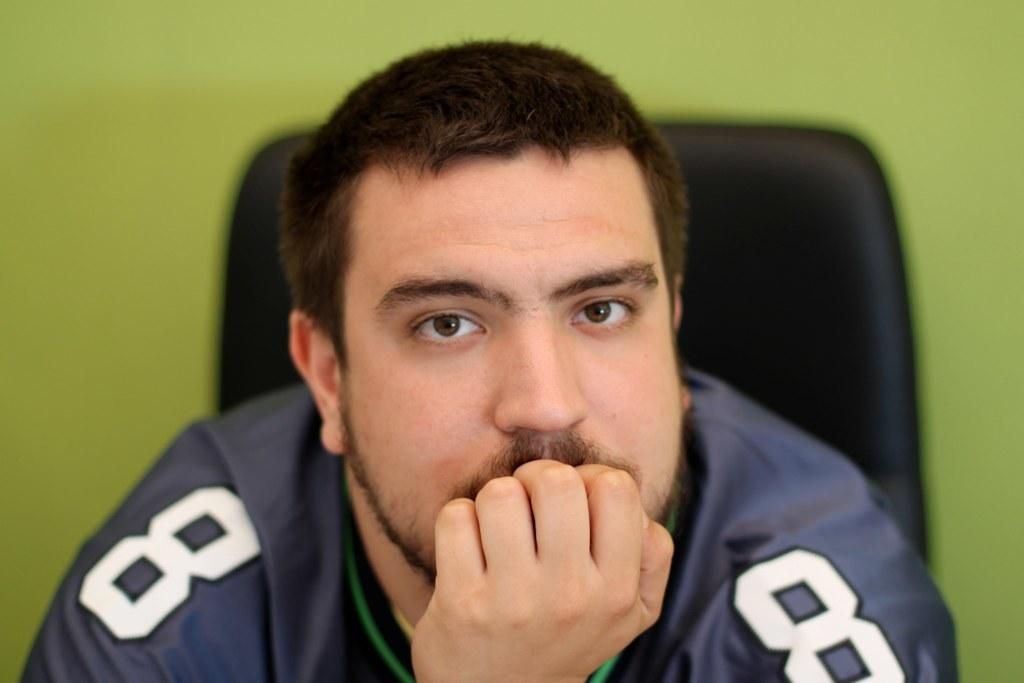What is the main subject of the image? There is a person in the image. Can you describe the person's attire? The person is wearing a dress with green, blue, and white colors. What is the person doing in the image? The person is sitting on a chair. What is the color of the chair? The chair is black in color. What can be seen behind the person? There is a green colored background in the image. What type of mint is growing on the chair in the image? There is no mint present in the image; the person is sitting on a black chair with a green background. 